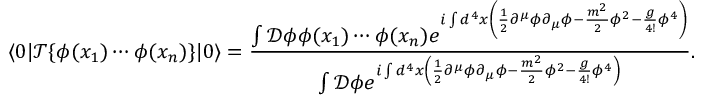<formula> <loc_0><loc_0><loc_500><loc_500>\langle 0 | { \mathcal { T } } \{ \phi ( x _ { 1 } ) \cdots \phi ( x _ { n } ) \} | 0 \rangle = { \frac { \int { \mathcal { D } } \phi \phi ( x _ { 1 } ) \cdots \phi ( x _ { n } ) e ^ { i \int d ^ { 4 } x \left ( { \frac { 1 } { 2 } } \partial ^ { \mu } \phi \partial _ { \mu } \phi - { \frac { m ^ { 2 } } { 2 } } \phi ^ { 2 } - { \frac { g } { 4 ! } } \phi ^ { 4 } \right ) } } { \int { \mathcal { D } } \phi e ^ { i \int d ^ { 4 } x \left ( { \frac { 1 } { 2 } } \partial ^ { \mu } \phi \partial _ { \mu } \phi - { \frac { m ^ { 2 } } { 2 } } \phi ^ { 2 } - { \frac { g } { 4 ! } } \phi ^ { 4 } \right ) } } } .</formula> 